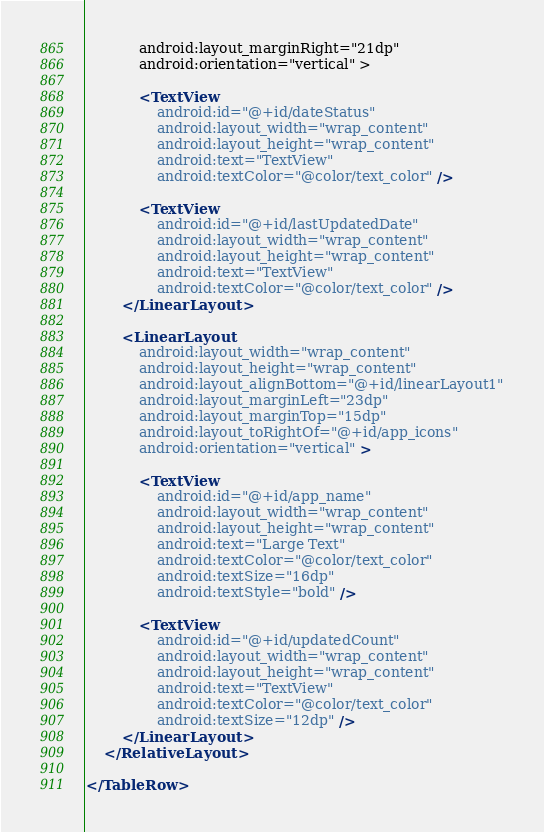<code> <loc_0><loc_0><loc_500><loc_500><_XML_>            android:layout_marginRight="21dp"
            android:orientation="vertical" >

            <TextView
                android:id="@+id/dateStatus"
                android:layout_width="wrap_content"
                android:layout_height="wrap_content"
                android:text="TextView"
                android:textColor="@color/text_color" />

            <TextView
                android:id="@+id/lastUpdatedDate"
                android:layout_width="wrap_content"
                android:layout_height="wrap_content"
                android:text="TextView"
                android:textColor="@color/text_color" />
        </LinearLayout>

        <LinearLayout
            android:layout_width="wrap_content"
            android:layout_height="wrap_content"
            android:layout_alignBottom="@+id/linearLayout1"
            android:layout_marginLeft="23dp"
            android:layout_marginTop="15dp"
            android:layout_toRightOf="@+id/app_icons"
            android:orientation="vertical" >

            <TextView
                android:id="@+id/app_name"
                android:layout_width="wrap_content"
                android:layout_height="wrap_content"
                android:text="Large Text"
                android:textColor="@color/text_color"
                android:textSize="16dp"
                android:textStyle="bold" />

            <TextView
                android:id="@+id/updatedCount"
                android:layout_width="wrap_content"
                android:layout_height="wrap_content"
                android:text="TextView"
                android:textColor="@color/text_color"
                android:textSize="12dp" />
        </LinearLayout>
    </RelativeLayout>

</TableRow></code> 